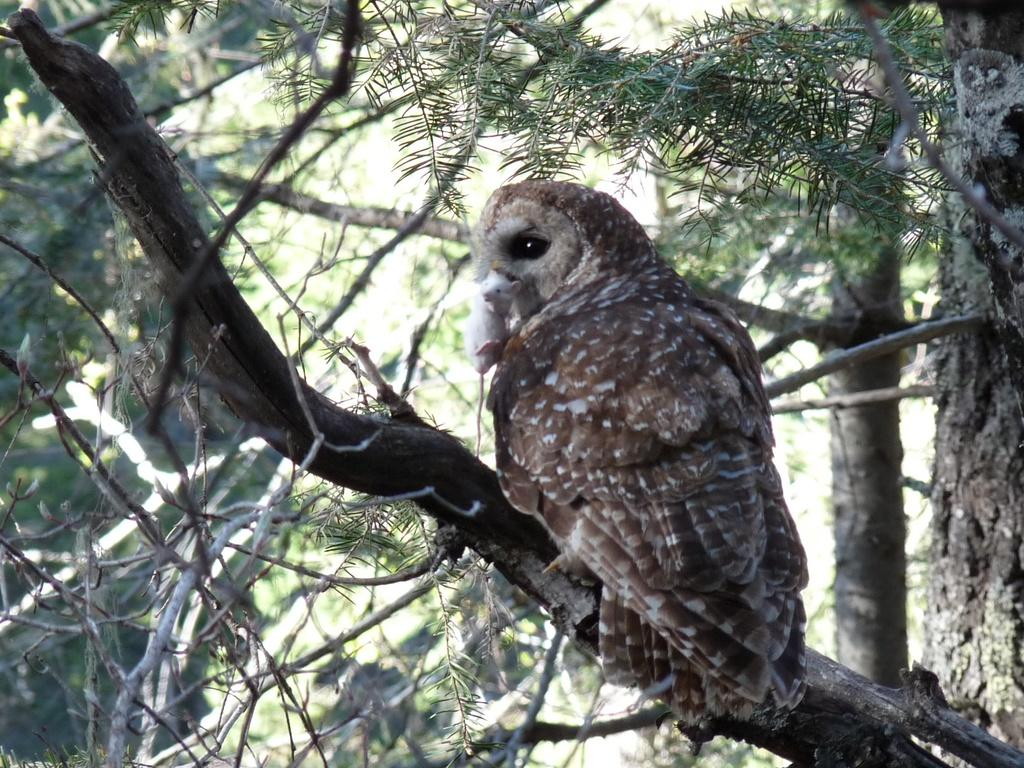What type of animal is in the image? There is an owl in the image. Where is the owl located? The owl is on a branch. Can you describe the position of the branch in the image? The branch is in the foreground area of the image. What can be seen in the background of the image? There are trees in the background of the image. What type of skirt is the owl wearing in the image? The owl is not wearing a skirt in the image, as it is a bird and does not wear clothing. 